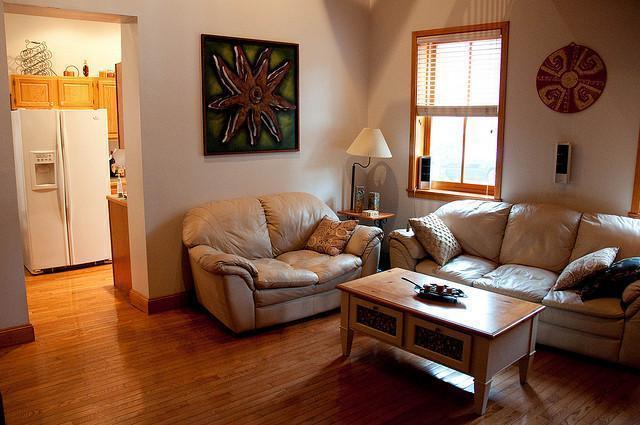What pair of devices are mounted on the wall and in the window sill?
Select the accurate answer and provide justification: `Answer: choice
Rationale: srationale.`
Options: Intercom, walkie-talkie, speaker, radio. Answer: speaker.
Rationale: Speakers take the form of the object on the wall. 